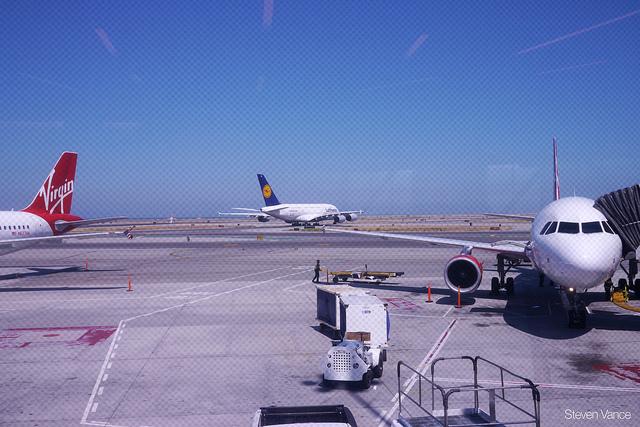Which side is the Virgin America plane on?
Short answer required. Left. Do you see a plane with a red wing?
Quick response, please. Yes. How many planes?
Keep it brief. 3. 